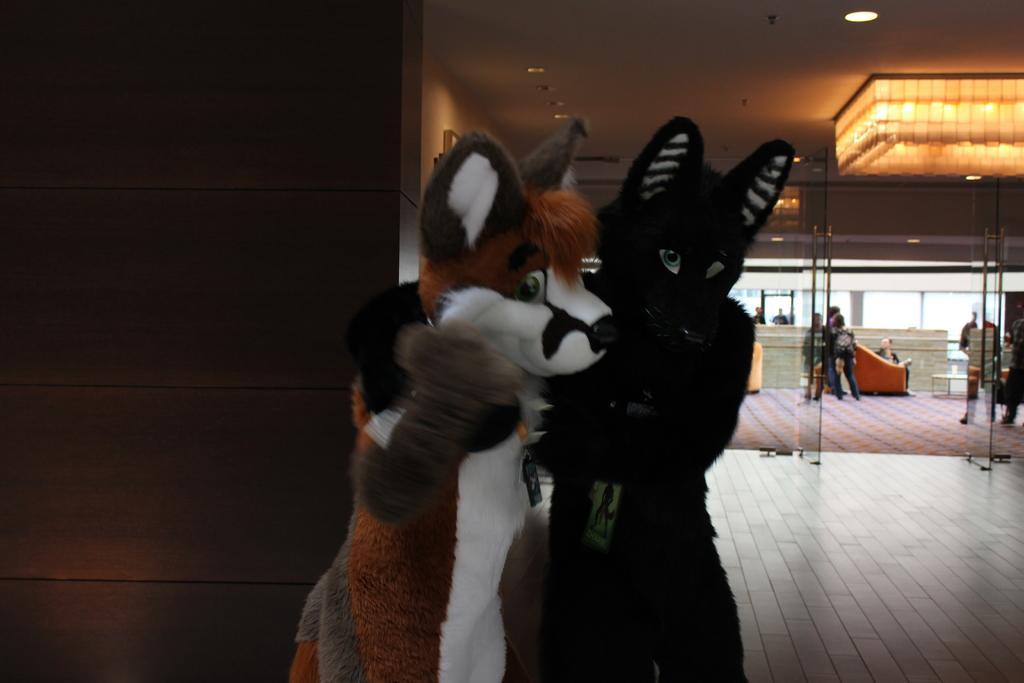How would you summarize this image in a sentence or two? This picture shows the inner view of a building. There are some lights attached to the ceiling, one frame attached to the wall, three Sofa chairs, some people standing, some people are walking, one person wearing a bag, some people holding objects, two big soft toys with ID cards near the wall which resembles animals, one person sitting on the Sofa chair, one object on the floor and one object near the Sofa chair looks like a small wall. 